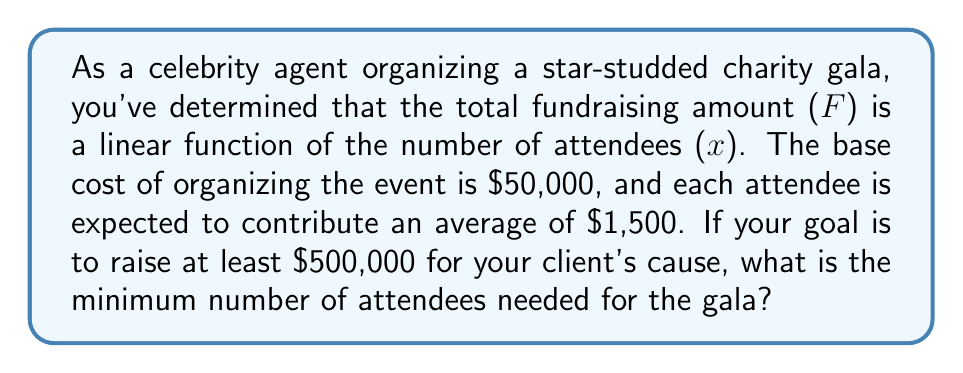What is the answer to this math problem? Let's approach this step-by-step:

1) First, we need to establish the linear function that represents the total fundraising amount:

   $F(x) = 1500x - 50000$

   Where:
   - $F(x)$ is the total fundraising amount
   - $x$ is the number of attendees
   - 1500 is the average contribution per attendee
   - 50000 is the base cost of organizing the event

2) We want to find the minimum number of attendees needed to raise at least $500,000. This can be represented as:

   $F(x) \geq 500000$

3) Substituting our function:

   $1500x - 50000 \geq 500000$

4) Now, let's solve this inequality:

   $1500x \geq 550000$
   
   $x \geq \frac{550000}{1500}$
   
   $x \geq 366.67$

5) Since we can't have a fractional number of attendees, we need to round up to the nearest whole number.
Answer: The minimum number of attendees needed is 367. 